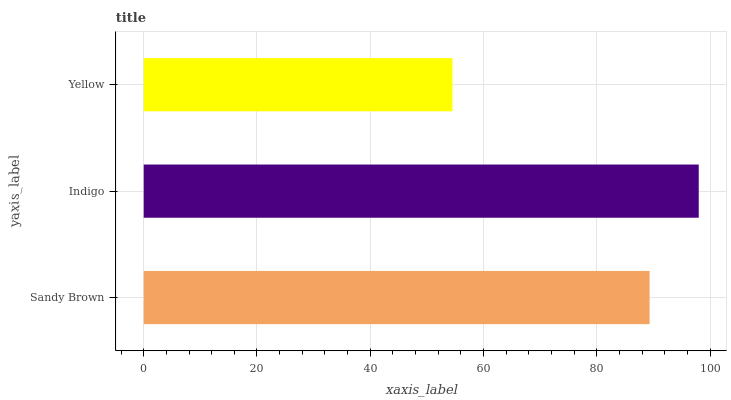Is Yellow the minimum?
Answer yes or no. Yes. Is Indigo the maximum?
Answer yes or no. Yes. Is Indigo the minimum?
Answer yes or no. No. Is Yellow the maximum?
Answer yes or no. No. Is Indigo greater than Yellow?
Answer yes or no. Yes. Is Yellow less than Indigo?
Answer yes or no. Yes. Is Yellow greater than Indigo?
Answer yes or no. No. Is Indigo less than Yellow?
Answer yes or no. No. Is Sandy Brown the high median?
Answer yes or no. Yes. Is Sandy Brown the low median?
Answer yes or no. Yes. Is Indigo the high median?
Answer yes or no. No. Is Indigo the low median?
Answer yes or no. No. 